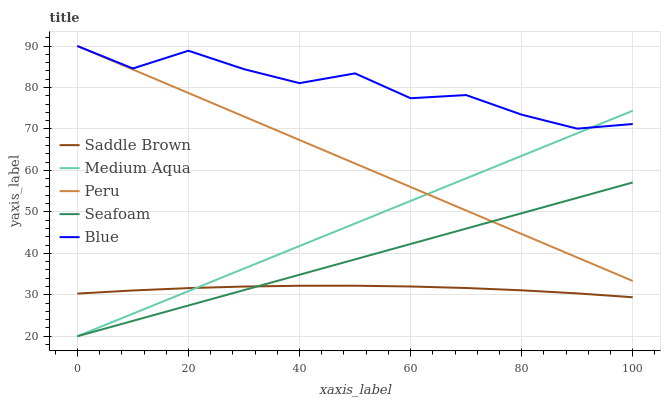Does Medium Aqua have the minimum area under the curve?
Answer yes or no. No. Does Medium Aqua have the maximum area under the curve?
Answer yes or no. No. Is Saddle Brown the smoothest?
Answer yes or no. No. Is Saddle Brown the roughest?
Answer yes or no. No. Does Saddle Brown have the lowest value?
Answer yes or no. No. Does Medium Aqua have the highest value?
Answer yes or no. No. Is Saddle Brown less than Peru?
Answer yes or no. Yes. Is Peru greater than Saddle Brown?
Answer yes or no. Yes. Does Saddle Brown intersect Peru?
Answer yes or no. No. 